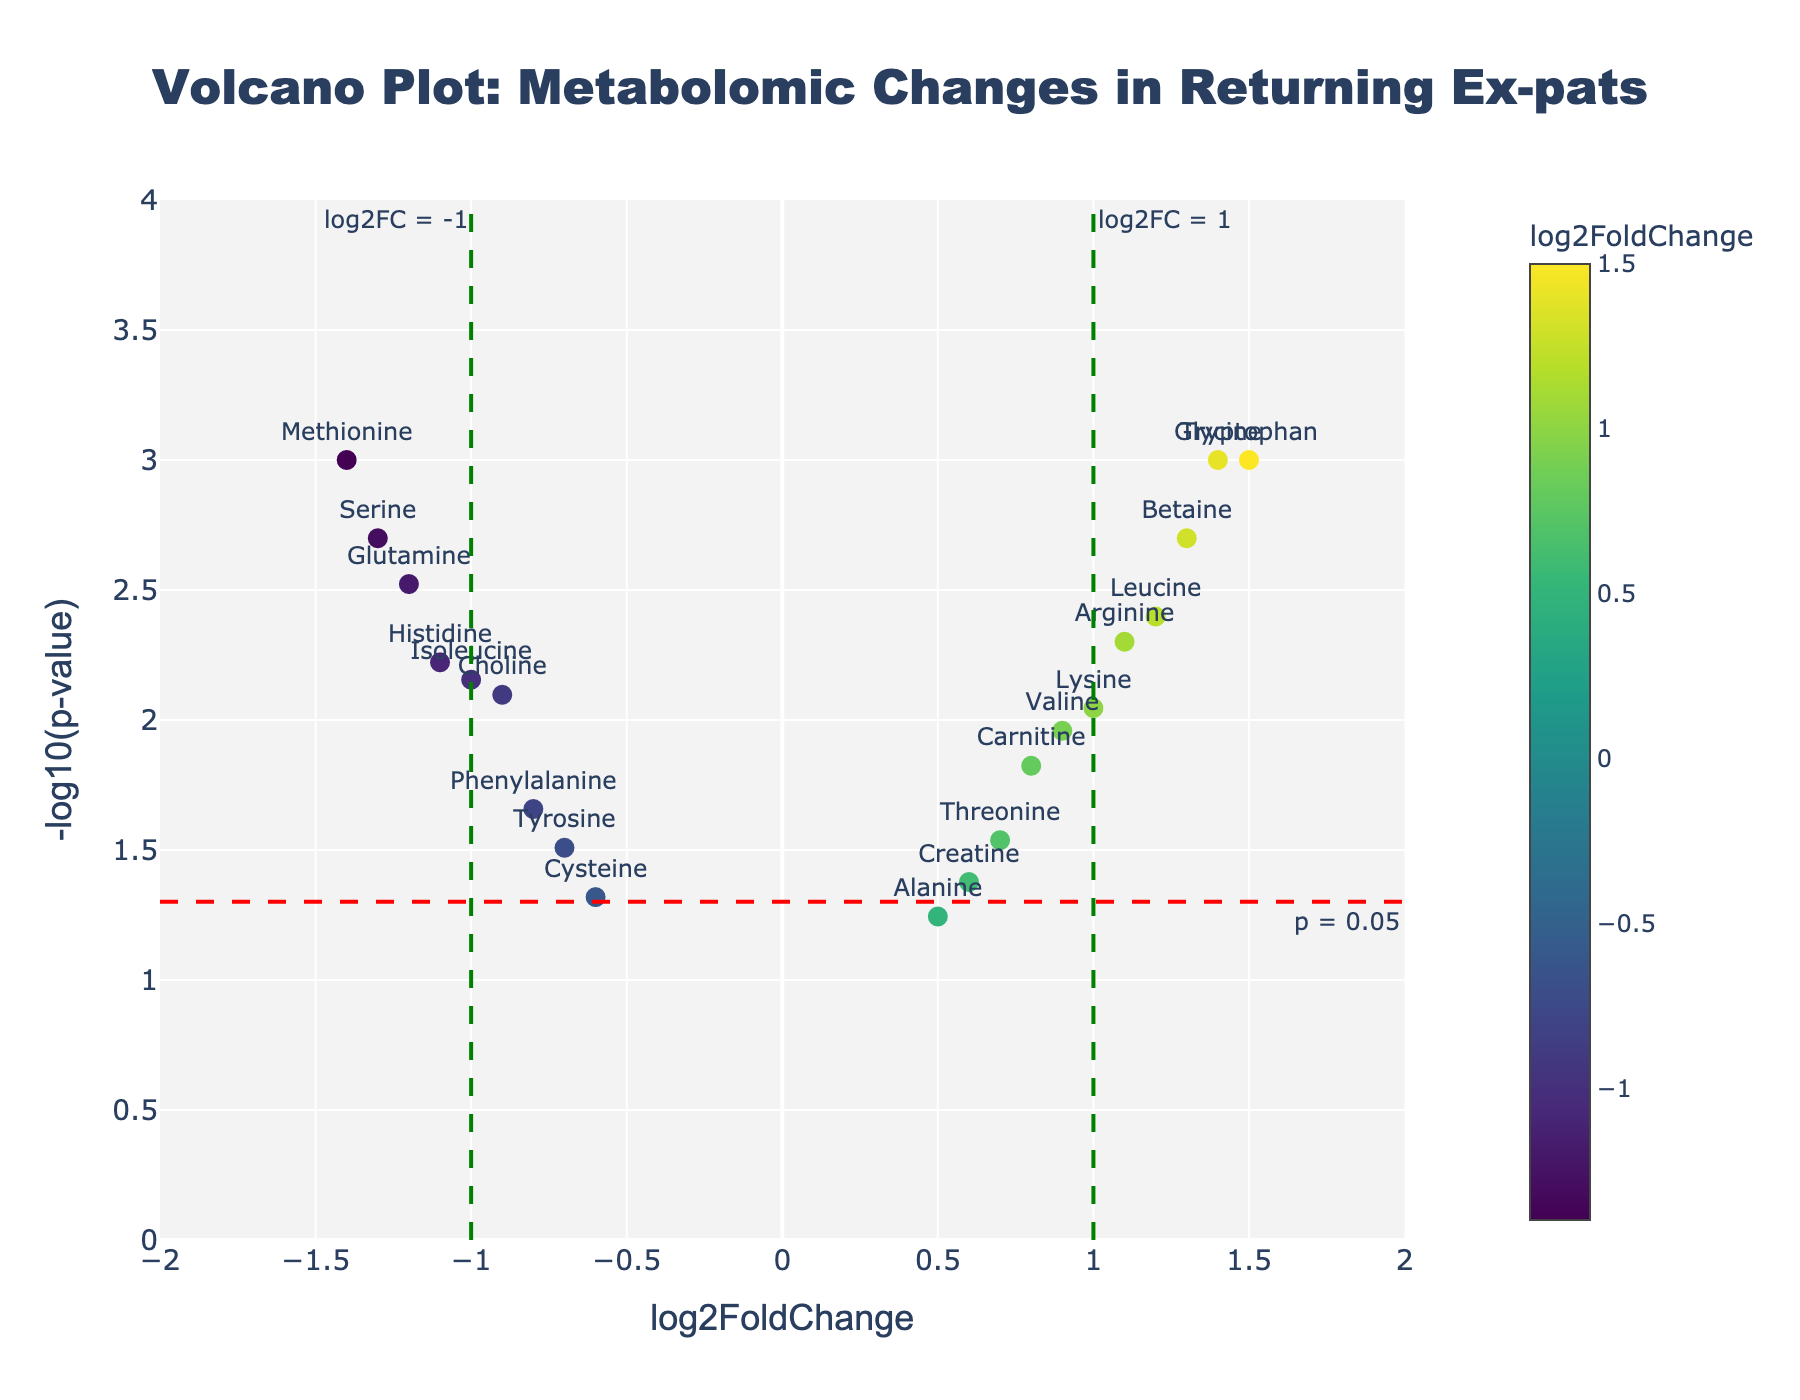What is the title of the volcano plot? The title is written at the top center of the plot, indicating what the data represents.
Answer: Volcano Plot: Metabolomic Changes in Returning Ex-pats What do the x-axis and y-axis represent in the plot? The x-axis indicates the log2FoldChange of metabolites and the y-axis represents the -log10 of the p-value of the changes. These are labeled on the respective axes.
Answer: log2FoldChange and -log10(p-value) How many metabolites have a log2FoldChange greater than 1? Count the number of data points positioned right of the vertical line at log2FoldChange = 1.
Answer: 5 Which metabolite shows the highest statistical significance (lowest p-value)? Locate the data point highest on the y-axis, which represents -log10(p-value). This corresponds to the smallest p-value.
Answer: Tryptophan Which metabolites have a log2FoldChange between -1 and 1 and a p-value less than 0.05? Identify data points within -1 < log2FoldChange < 1 and y > -log10(0.05), then read their labels.
Answer: Carnitine, Choline, Histidine, Tyrosine, Creatine, Threonine What is the log2FoldChange for Methionine? Locate Methionine in the plot and read its x-axis value.
Answer: -1.4 How many metabolites have a p-value less than 0.05? Count the number of data points above the horizontal line at -log10(0.05).
Answer: 17 Which two metabolites have the most extreme positive and negative log2FoldChanges? Identify the data points farthest to the right and left, and read their labels.
Answer: Tryptophan and Methionine How many metabolites show a statistically significant change in expression with log2FoldChange greater than or equal to 1 or less than or equal to -1? Count the number of points outside [-1, 1] on the x-axis within the region above the horizontal line for p < 0.05.
Answer: 8 What does the color gradient in the plot indicate? The color gradient represents the log2FoldChange values, where different colors denote higher or lower expression changes, as indicated by the color bar.
Answer: log2FoldChange 